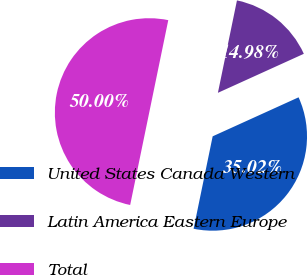Convert chart. <chart><loc_0><loc_0><loc_500><loc_500><pie_chart><fcel>United States Canada Western<fcel>Latin America Eastern Europe<fcel>Total<nl><fcel>35.02%<fcel>14.98%<fcel>50.0%<nl></chart> 